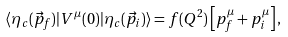<formula> <loc_0><loc_0><loc_500><loc_500>\langle \eta _ { c } ( \vec { p } _ { f } ) | V ^ { \mu } ( 0 ) | \eta _ { c } ( \vec { p } _ { i } ) \rangle = f ( Q ^ { 2 } ) \left [ p _ { f } ^ { \mu } + p _ { i } ^ { \mu } \right ] ,</formula> 